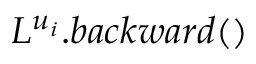Convert formula to latex. <formula><loc_0><loc_0><loc_500><loc_500>L ^ { u _ { i } } . b a c k w a r d ( )</formula> 